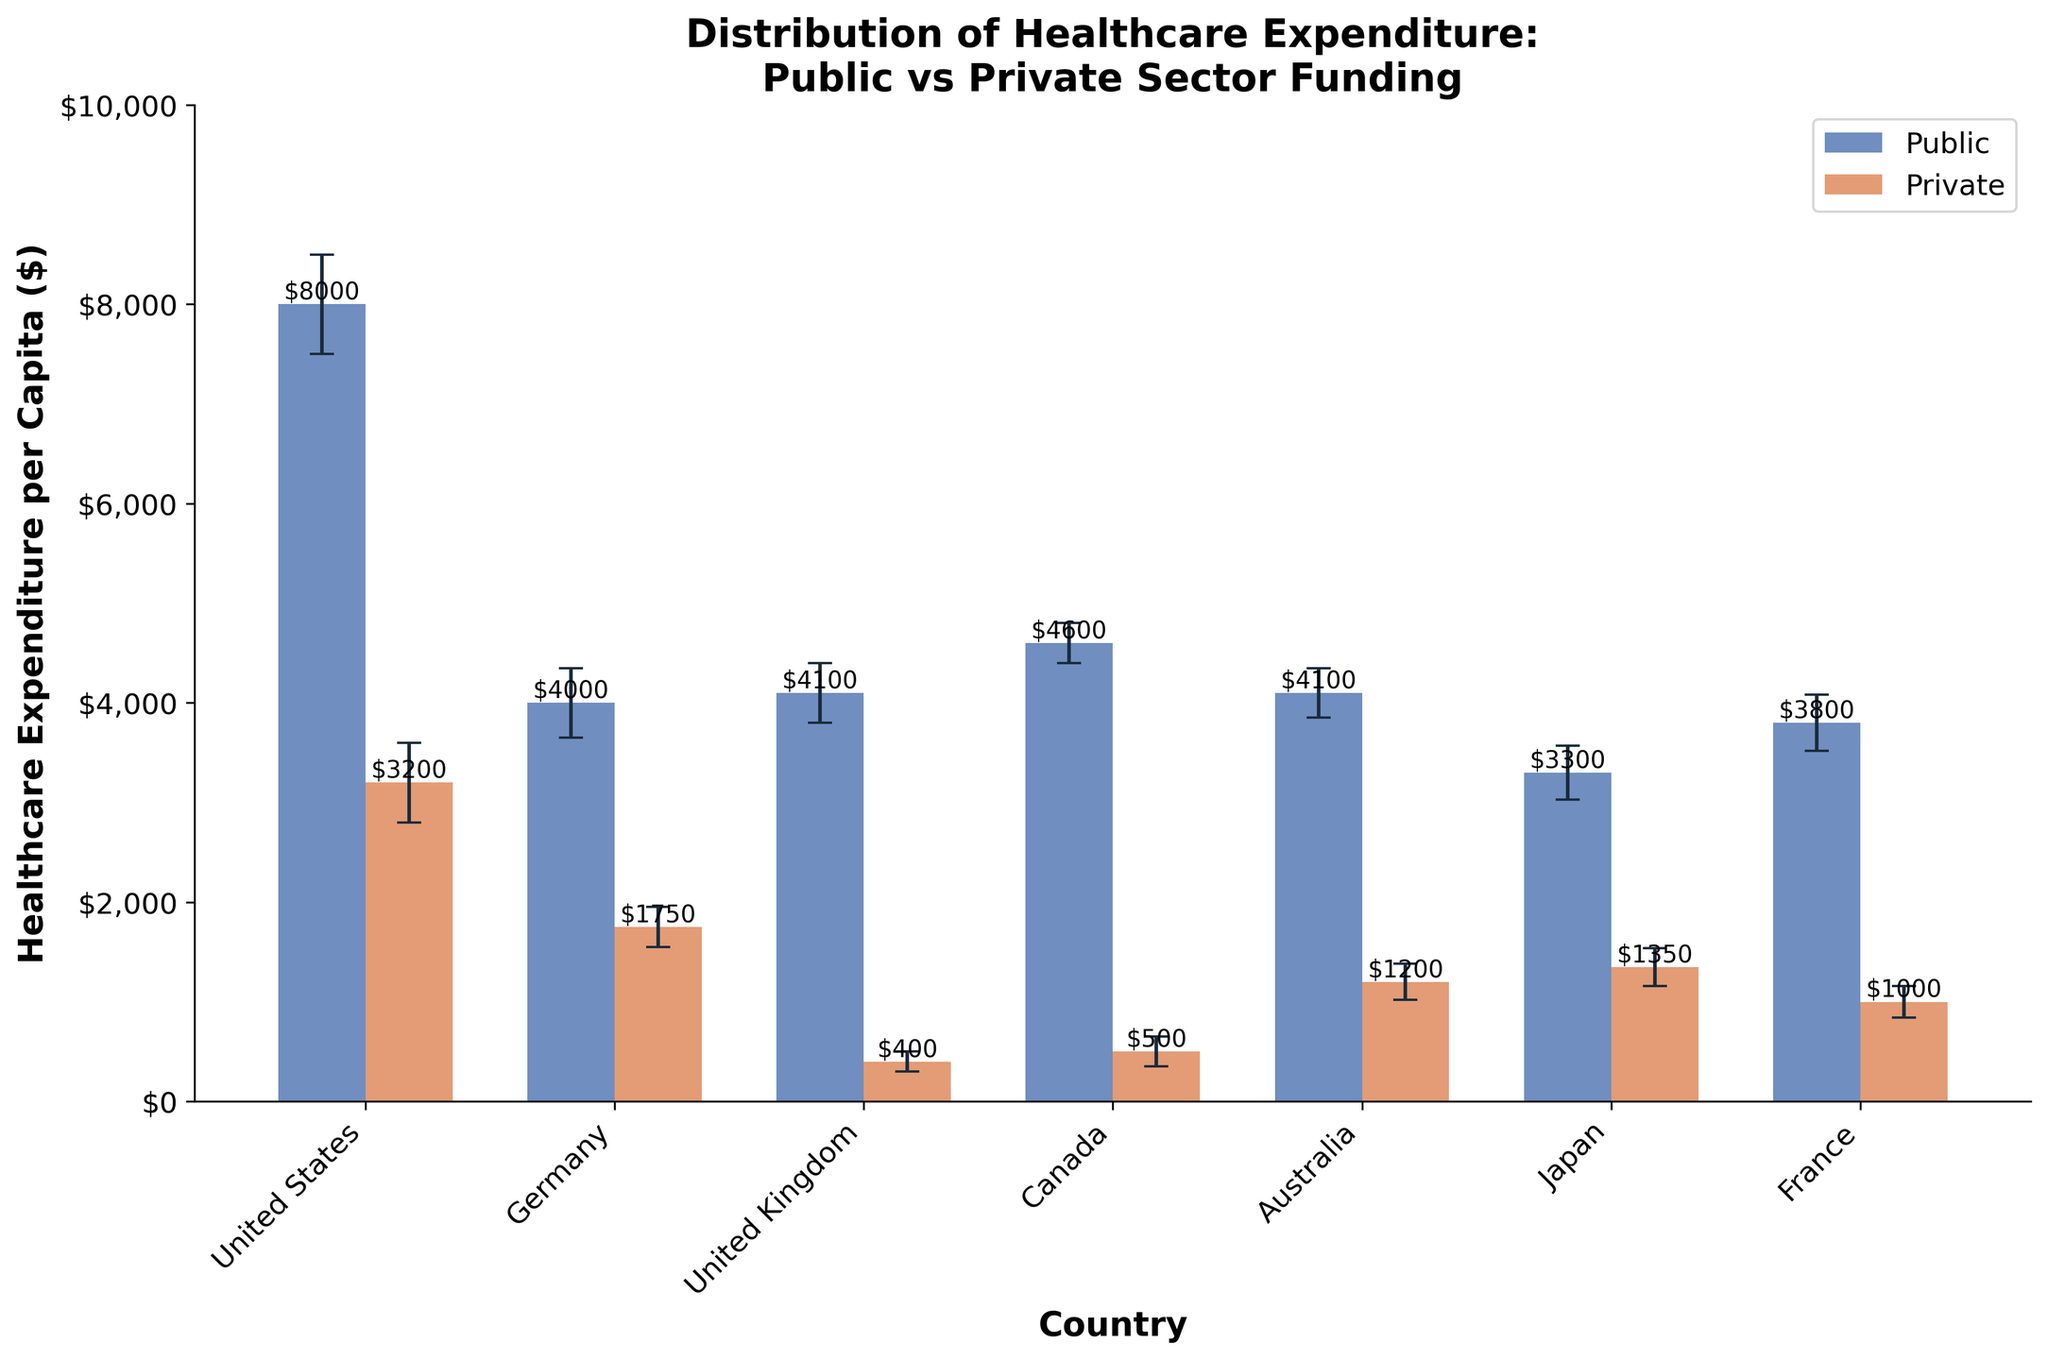What is the title of the figure? The figure's title is generally found at the top of the plot in larger font size. It describes the content and scope of the figure. The title here is "Distribution of Healthcare Expenditure: Public vs Private Sector Funding".
Answer: Distribution of Healthcare Expenditure: Public vs Private Sector Funding Which country has the highest public healthcare expenditure per capita? Looking at the height of the bars representing public healthcare expenditure, we see that the United States has the highest public expenditure at $8000.
Answer: United States What are the error margins for Germany's private healthcare expenditure? Error bars denote the error margins for each bar. For Germany’s private healthcare expenditure, the height of the bar is $1750, and the error margin is given as $\pm 200.
Answer: ±$200 In which country is the gap between public and private healthcare expenditure per capita the greatest? To find the greatest gap, calculate the difference between public and private expenditure for each country. The United States has a difference of $8000 (public) - $3200 (private) = $4800, which is the highest.
Answer: United States Which country's private healthcare expenditure per capita has the smallest error bar? The error bar with the smallest range for private expenditure is for the United Kingdom, with an error margin of ±$100.
Answer: United Kingdom Is there any country where private healthcare expenditure exceeds public healthcare expenditure? By inspecting the heights of bars for both categories, no country shows private expenditure exceeding public expenditure; public is always greater.
Answer: No What is the combined average healthcare expenditure per capita for public and private sectors in Canada? The combined average healthcare expenditure per capita is (4600 + 500) / 2 for Canada, which equals $2550.
Answer: $2550 Which country has the closest gap between public and private healthcare expenditure per capita? By calculating the differences: United Kingdom has the smallest gap of $4100 (public) - $400 (private) = $370.
Answer: United Kingdom How does Japan's public healthcare expenditure per capita compare to Canada's? Japan’s public expenditure is $3300, while Canada’s public expenditure is $4600. Japan's expenditure is lower by $1300 compared to Canada's.
Answer: Japan's is lower What is the mean public healthcare expenditure per capita across all countries? To find the mean, sum all public expenditures and divide by the number of countries: (8000 + 4000 + 4100 + 4600 + 4100 + 3300 + 3800) / 7 = 40,900 / 7 ≈ 5857.14.
Answer: $5857.14 